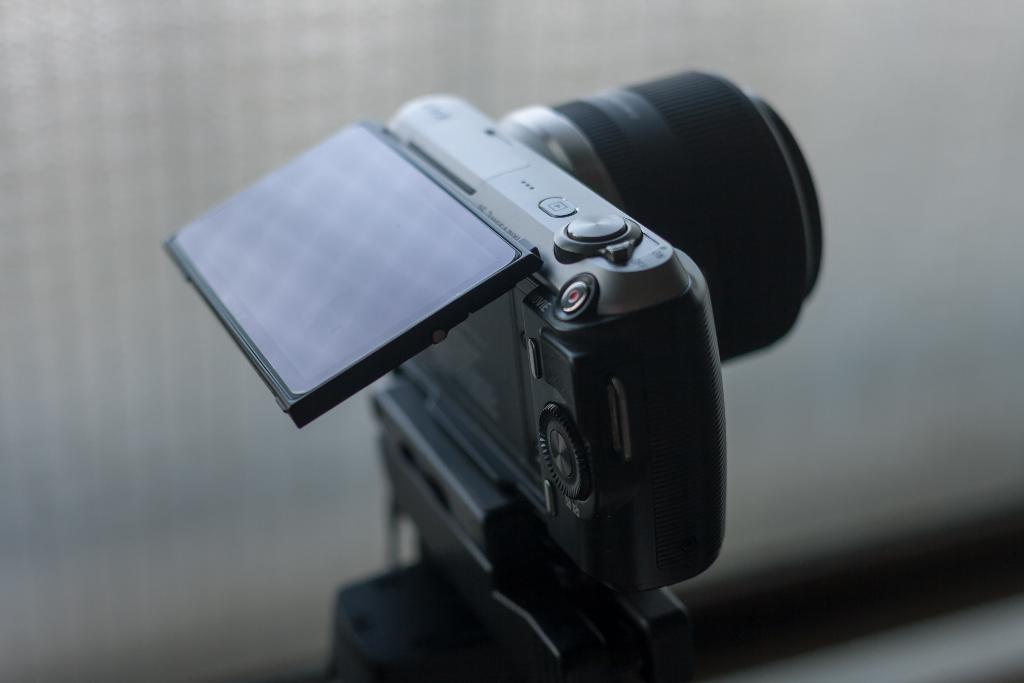What object is the main subject of the image? There is a camera in the image. Can you describe the background of the image? The background of the image is blurry. How many ants can be seen crawling on the camera in the image? There are no ants present in the image; it features a camera with a blurry background. What type of scissors are used to cut the camera in the image? There is no cutting or scissors present in the image; it features a camera with a blurry background. 